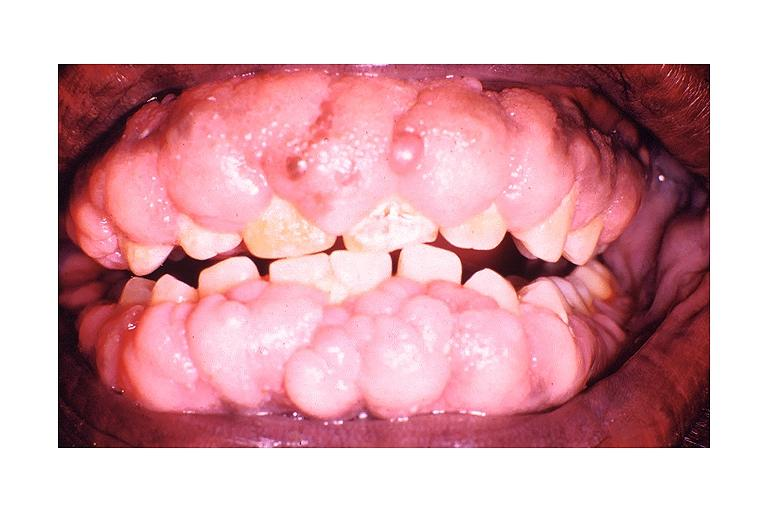does immunoperoxidate show dilantin induced gingival hyperplasia?
Answer the question using a single word or phrase. No 